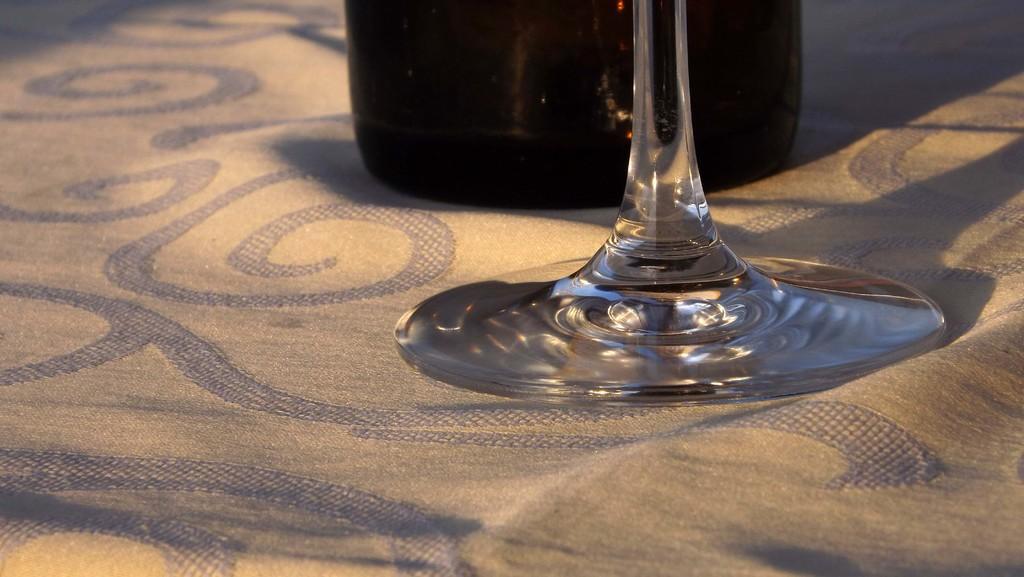Describe this image in one or two sentences. In the image it looks like there is a bottle and a glass kept on a cloth. 